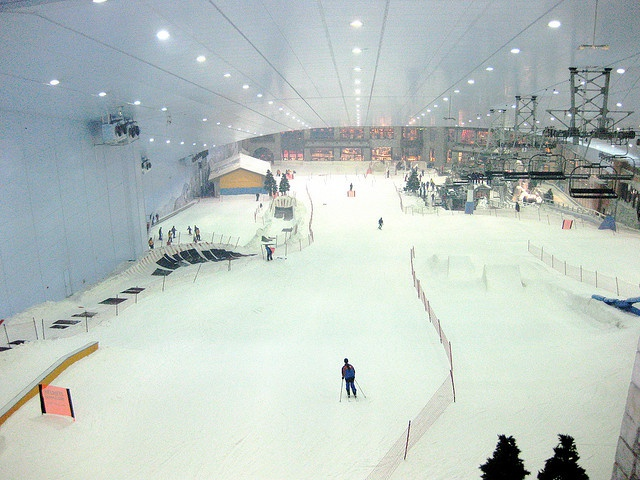Describe the objects in this image and their specific colors. I can see people in gray, ivory, darkgray, and beige tones, people in gray, black, navy, and blue tones, people in gray, teal, and black tones, people in gray, darkgray, navy, and tan tones, and people in gray, ivory, and darkgray tones in this image. 